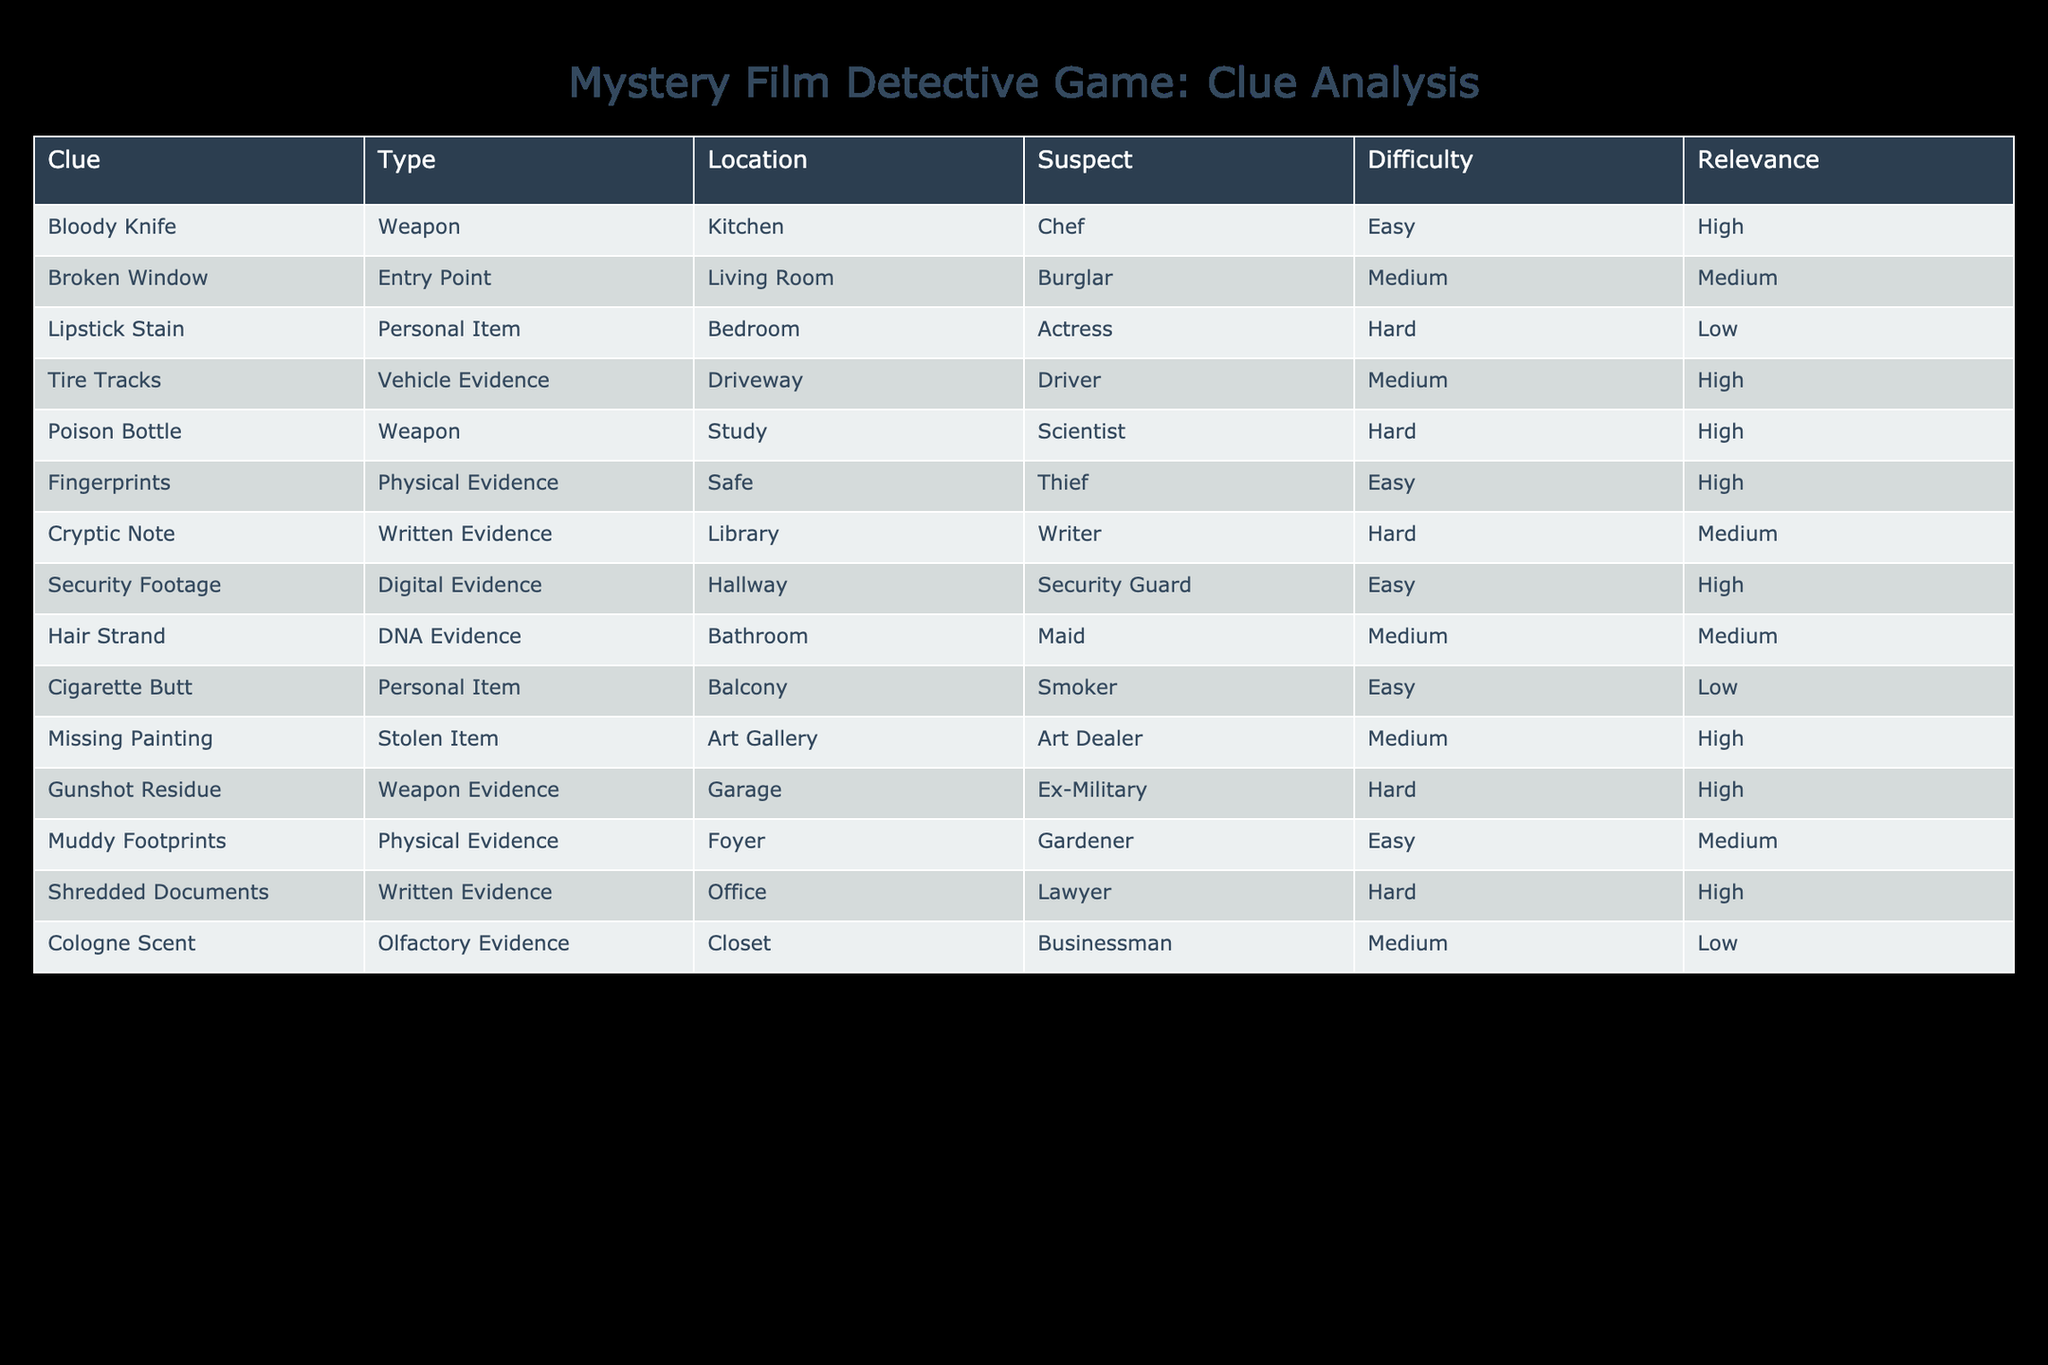What type of evidence is the "Bloody Knife"? The "Bloody Knife" is classified as a Weapon according to the table.
Answer: Weapon Which location has the highest difficulty level clue? The "Poison Bottle" and "Gunshot Residue" both possess a difficulty level marked as Hard; however, when looking for the singular highest, it can be said they share that characteristic.
Answer: Poison Bottle / Gunshot Residue Are there any suspects associated with "Written Evidence"? Yes, there are two clues classified as "Written Evidence": "Cryptic Note" linked to the Writer and "Shredded Documents" associated with the Lawyer.
Answer: Yes What is the average difficulty of clues that are classified as Physical Evidence? The Physical Evidence clues are "Fingerprints," "Muddy Footprints," and "Tire Tracks," with respective difficulty levels Easy, Easy, and Medium (considering Medium as 2), thus the average is (1 + 1 + 2) / 3 = 4 / 3 ≈ 1.33, which falls between Easy and Medium.
Answer: Approximately 1.33 How many clues have a "High" relevance rating? Upon counting, there are five clues with a "High" relevance rating, specifically "Bloody Knife," "Tire Tracks," "Poison Bottle," "Fingerprints," and "Gunshot Residue."
Answer: Five Which suspect is associated with the "Cigarette Butt"? The "Cigarette Butt" is associated with the Smoker, as indicated in the table.
Answer: Smoker Is there a clue located in the Art Gallery? Yes, the “Missing Painting” is the clue located in the Art Gallery, as specified in the table.
Answer: Yes What is the total number of clues that are considered "Medium" difficulty? The clues classified as Medium difficulty are "Broken Window," "Tire Tracks," "Hair Strand," and "Cologne Scent," which totals four clues.
Answer: Four What type of evidence is found in the study? The type of evidence found in the study is a Poison Bottle, categorized as a Weapon.
Answer: Weapon 